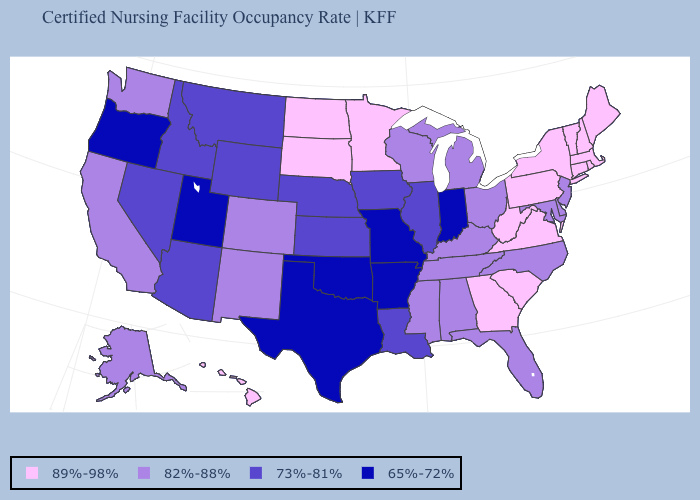What is the value of Massachusetts?
Write a very short answer. 89%-98%. Does Kentucky have a higher value than Louisiana?
Concise answer only. Yes. What is the value of Nevada?
Answer briefly. 73%-81%. Name the states that have a value in the range 82%-88%?
Be succinct. Alabama, Alaska, California, Colorado, Delaware, Florida, Kentucky, Maryland, Michigan, Mississippi, New Jersey, New Mexico, North Carolina, Ohio, Tennessee, Washington, Wisconsin. What is the value of Vermont?
Short answer required. 89%-98%. Does Utah have a lower value than North Carolina?
Short answer required. Yes. What is the value of Virginia?
Concise answer only. 89%-98%. Does North Dakota have the lowest value in the USA?
Quick response, please. No. What is the value of South Dakota?
Keep it brief. 89%-98%. Which states have the lowest value in the South?
Give a very brief answer. Arkansas, Oklahoma, Texas. What is the value of Florida?
Give a very brief answer. 82%-88%. Does Texas have the lowest value in the South?
Be succinct. Yes. What is the value of Texas?
Quick response, please. 65%-72%. Name the states that have a value in the range 82%-88%?
Answer briefly. Alabama, Alaska, California, Colorado, Delaware, Florida, Kentucky, Maryland, Michigan, Mississippi, New Jersey, New Mexico, North Carolina, Ohio, Tennessee, Washington, Wisconsin. Among the states that border Idaho , which have the highest value?
Give a very brief answer. Washington. 